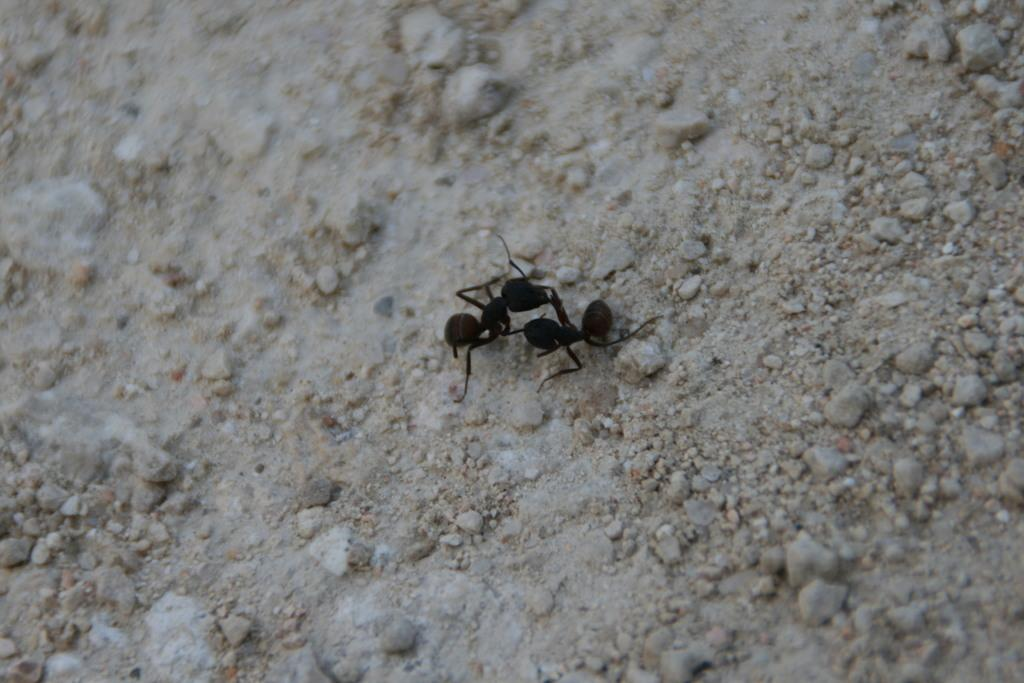What creatures can be seen in the foreground of the image? There are two black ants in the foreground of the image. Where are the ants located? The ants are on the ground. What other elements can be seen in the image? There are small stones in the image. What type of berry is being held by the doll in the image? There are no dolls present in the image, so it is not possible to answer that question. 